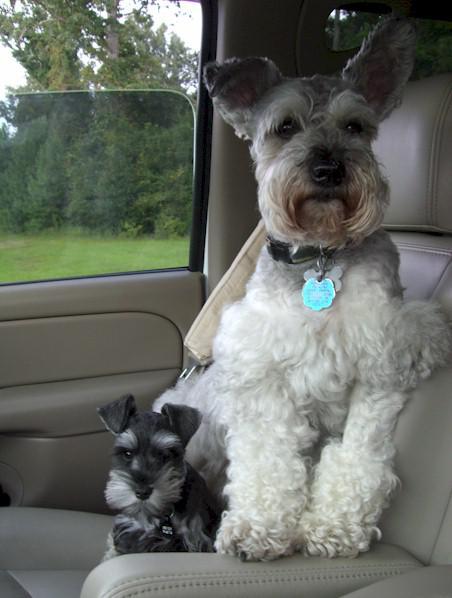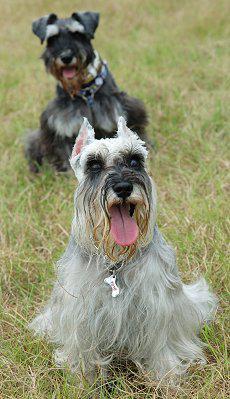The first image is the image on the left, the second image is the image on the right. For the images displayed, is the sentence "An image shows two schnauzers of similar size and coloring posed side-by-side." factually correct? Answer yes or no. No. The first image is the image on the left, the second image is the image on the right. Considering the images on both sides, is "At least one dog is showing its tongue." valid? Answer yes or no. Yes. 